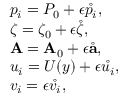Convert formula to latex. <formula><loc_0><loc_0><loc_500><loc_500>\begin{array} { r l } & { p _ { i } = P _ { 0 } + \epsilon \mathring { p _ { i } } , } \\ & { \zeta = \zeta _ { 0 } + \epsilon \mathring { \zeta } , } \\ & { { A } = { A } _ { 0 } + \epsilon \mathring { a } , } \\ & { u _ { i } = U ( y ) + \epsilon \mathring { u _ { i } } , } \\ & { v _ { i } = \epsilon \mathring { v _ { i } } , } \end{array}</formula> 